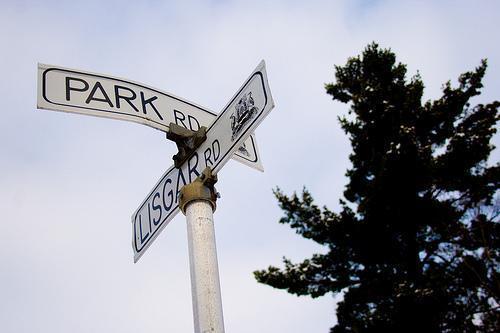How many signs?
Give a very brief answer. 2. How many PARK RD signs?
Give a very brief answer. 1. 